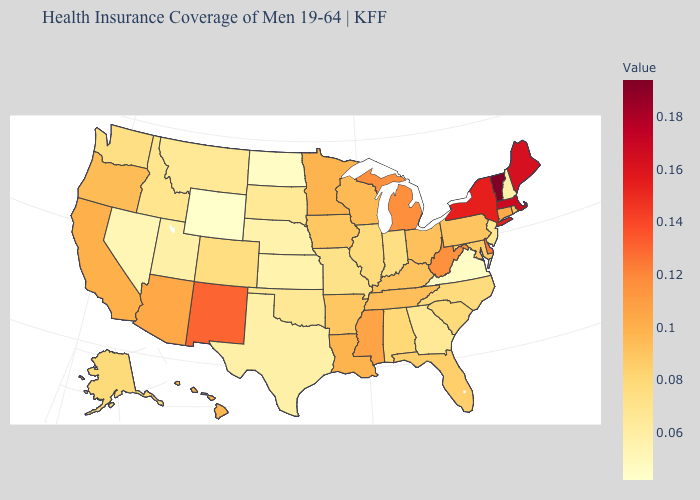Which states hav the highest value in the South?
Give a very brief answer. Delaware. Which states hav the highest value in the Northeast?
Quick response, please. Vermont. Which states have the lowest value in the USA?
Give a very brief answer. Wyoming. Among the states that border Wisconsin , which have the lowest value?
Quick response, please. Illinois. 